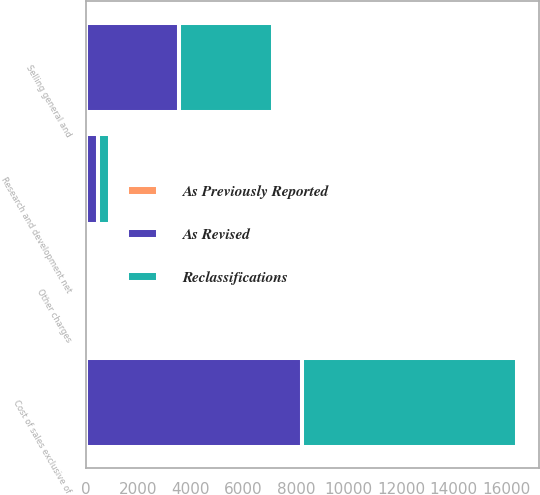Convert chart to OTSL. <chart><loc_0><loc_0><loc_500><loc_500><stacked_bar_chart><ecel><fcel>Cost of sales exclusive of<fcel>Selling general and<fcel>Research and development net<fcel>Other charges<nl><fcel>Reclassifications<fcel>8207<fcel>3564<fcel>453<fcel>64<nl><fcel>As Previously Reported<fcel>2<fcel>10<fcel>2<fcel>10<nl><fcel>As Revised<fcel>8209<fcel>3554<fcel>451<fcel>74<nl></chart> 